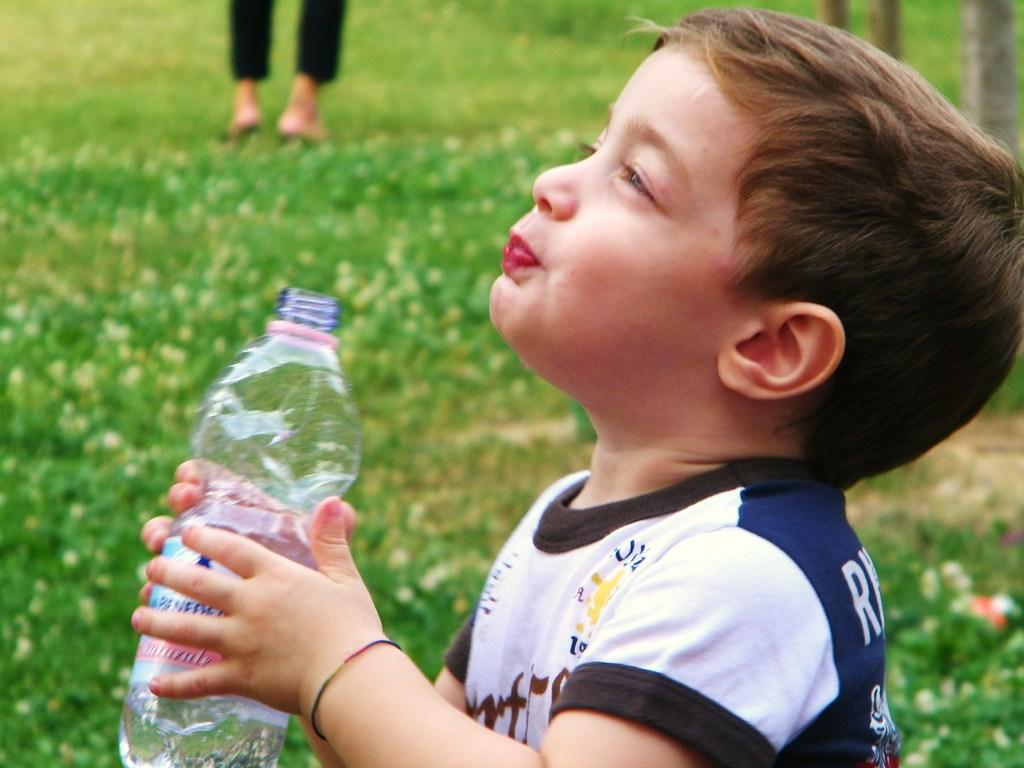What is the main subject of the image? There is a child in the image. What is the child wearing? The child is wearing a t-shirt. What is the child holding in his hand? The child is holding a bottle in his hand. What can be seen in the background of the image? There is grass in the background of the image, and a person's legs are also visible. Where is the flock of birds flying in the image? There are no birds visible in the image, so it is not possible to determine the location of a flock of birds. 